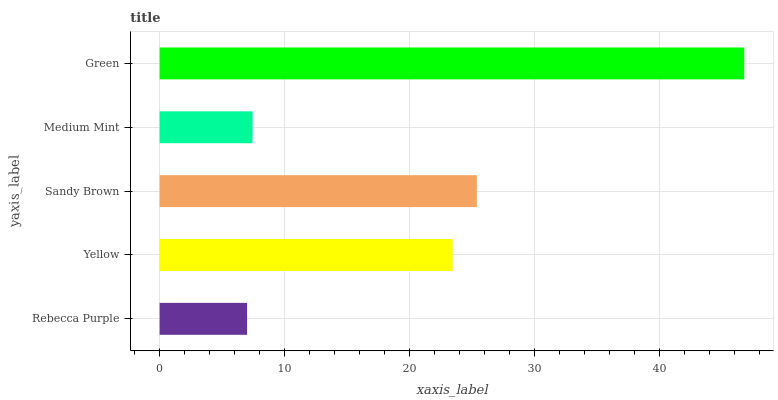Is Rebecca Purple the minimum?
Answer yes or no. Yes. Is Green the maximum?
Answer yes or no. Yes. Is Yellow the minimum?
Answer yes or no. No. Is Yellow the maximum?
Answer yes or no. No. Is Yellow greater than Rebecca Purple?
Answer yes or no. Yes. Is Rebecca Purple less than Yellow?
Answer yes or no. Yes. Is Rebecca Purple greater than Yellow?
Answer yes or no. No. Is Yellow less than Rebecca Purple?
Answer yes or no. No. Is Yellow the high median?
Answer yes or no. Yes. Is Yellow the low median?
Answer yes or no. Yes. Is Medium Mint the high median?
Answer yes or no. No. Is Medium Mint the low median?
Answer yes or no. No. 